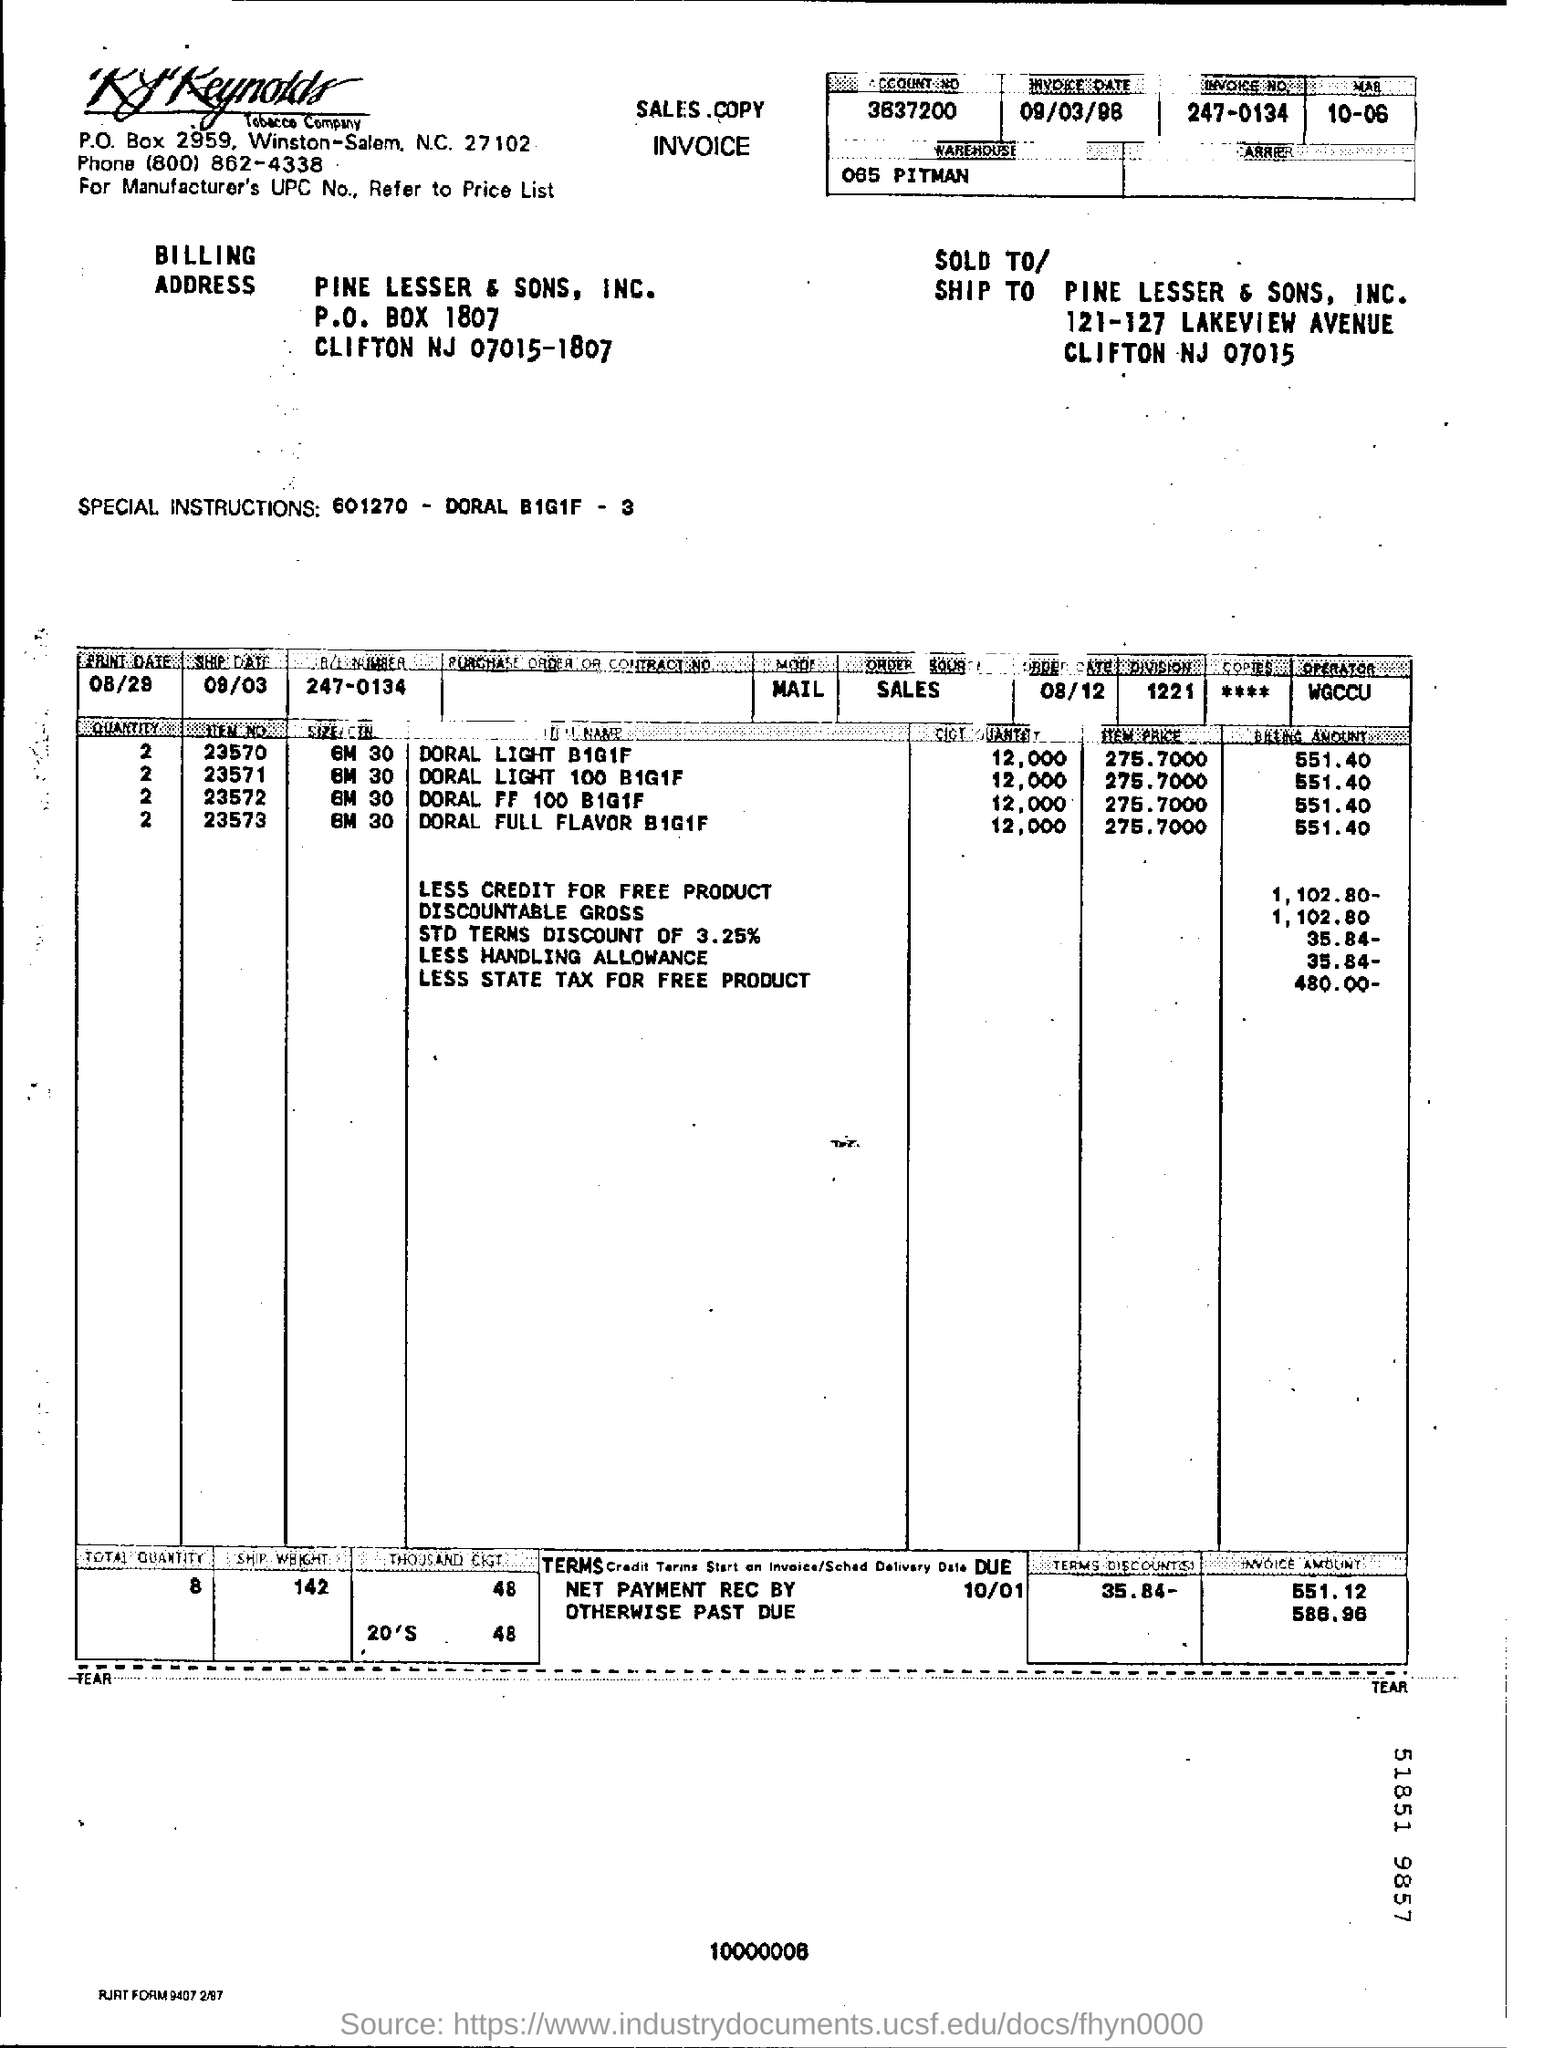Highlight a few significant elements in this photo. The invoice number is 247-0134. The item price of Doral Light when bought in bulk, B1G1F, is 275.7000. The account number on the sales copy invoice is 3637200... 